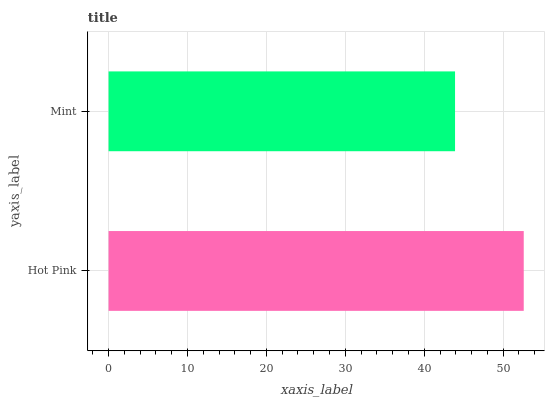Is Mint the minimum?
Answer yes or no. Yes. Is Hot Pink the maximum?
Answer yes or no. Yes. Is Mint the maximum?
Answer yes or no. No. Is Hot Pink greater than Mint?
Answer yes or no. Yes. Is Mint less than Hot Pink?
Answer yes or no. Yes. Is Mint greater than Hot Pink?
Answer yes or no. No. Is Hot Pink less than Mint?
Answer yes or no. No. Is Hot Pink the high median?
Answer yes or no. Yes. Is Mint the low median?
Answer yes or no. Yes. Is Mint the high median?
Answer yes or no. No. Is Hot Pink the low median?
Answer yes or no. No. 